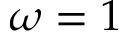<formula> <loc_0><loc_0><loc_500><loc_500>\omega = 1</formula> 